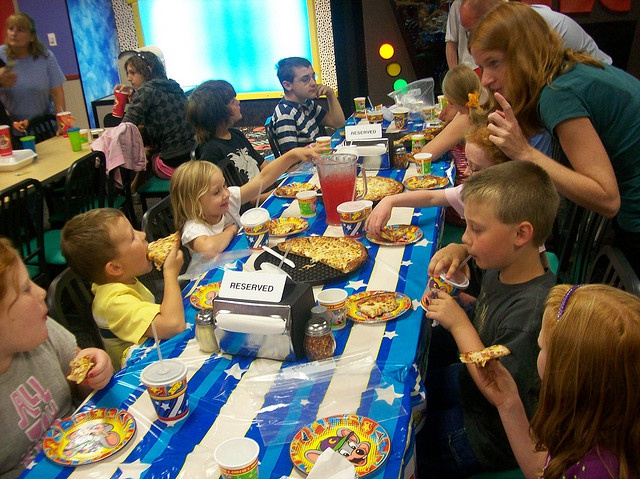Describe the objects in this image and their specific colors. I can see dining table in maroon, beige, blue, and darkgray tones, people in maroon, black, and brown tones, people in maroon, black, and brown tones, people in maroon, black, and brown tones, and chair in maroon, black, olive, and darkgreen tones in this image. 